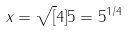Convert formula to latex. <formula><loc_0><loc_0><loc_500><loc_500>x = \sqrt { [ } 4 ] { 5 } = 5 ^ { 1 / 4 }</formula> 